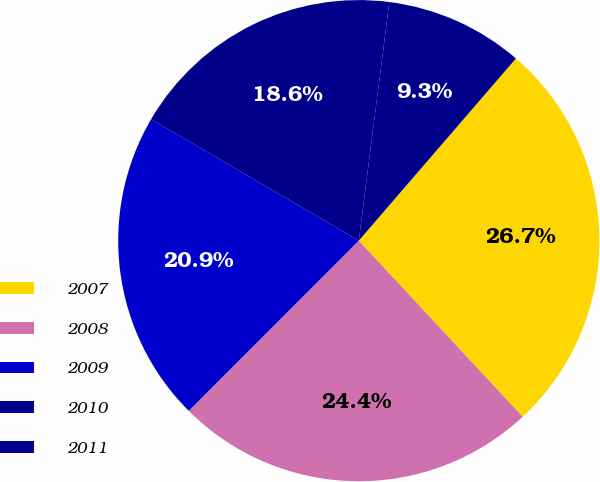Convert chart to OTSL. <chart><loc_0><loc_0><loc_500><loc_500><pie_chart><fcel>2007<fcel>2008<fcel>2009<fcel>2010<fcel>2011<nl><fcel>26.74%<fcel>24.42%<fcel>20.93%<fcel>18.6%<fcel>9.3%<nl></chart> 